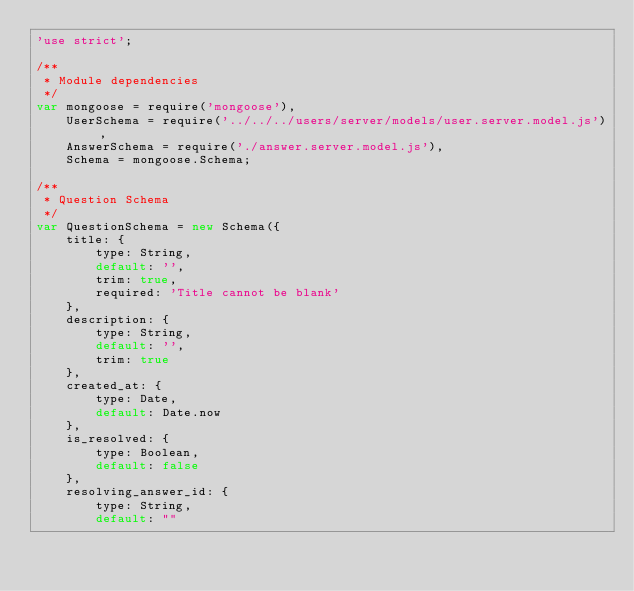Convert code to text. <code><loc_0><loc_0><loc_500><loc_500><_JavaScript_>'use strict';

/**
 * Module dependencies
 */
var mongoose = require('mongoose'),
    UserSchema = require('../../../users/server/models/user.server.model.js'),
    AnswerSchema = require('./answer.server.model.js'),
    Schema = mongoose.Schema;

/**
 * Question Schema
 */
var QuestionSchema = new Schema({
    title: {
        type: String,
        default: '',
        trim: true,
        required: 'Title cannot be blank'
    },
    description: {
        type: String,
        default: '',
        trim: true
    },
    created_at: {
        type: Date,
        default: Date.now
    },
    is_resolved: {
        type: Boolean,
        default: false
    },
    resolving_answer_id: {
        type: String,
        default: ""</code> 